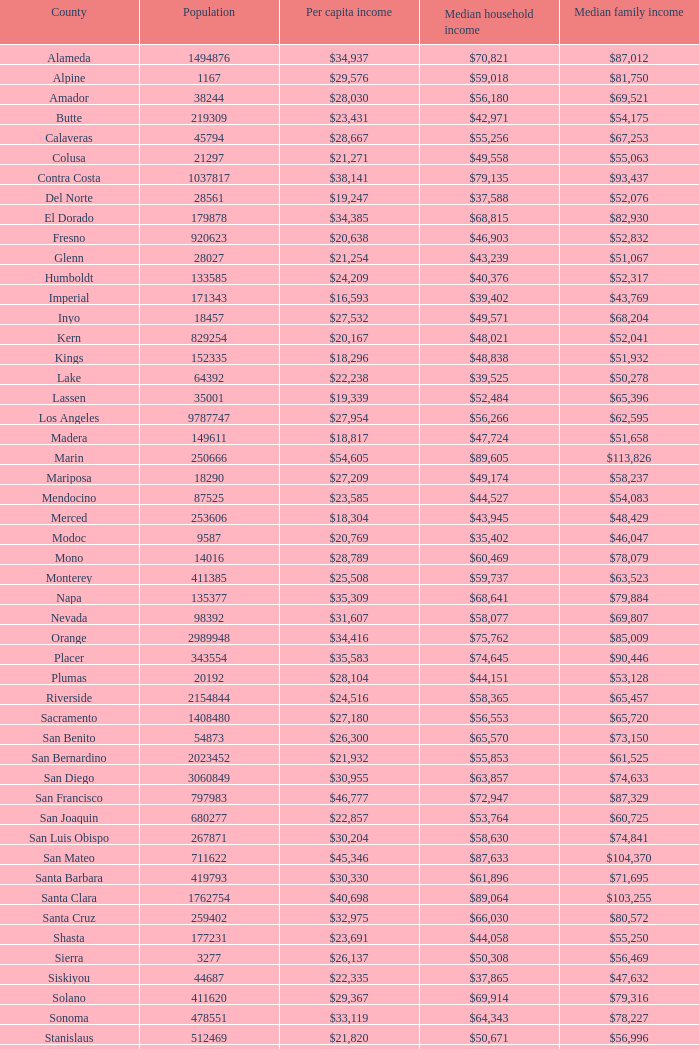Identify the middle family earnings in riverside. $65,457. 